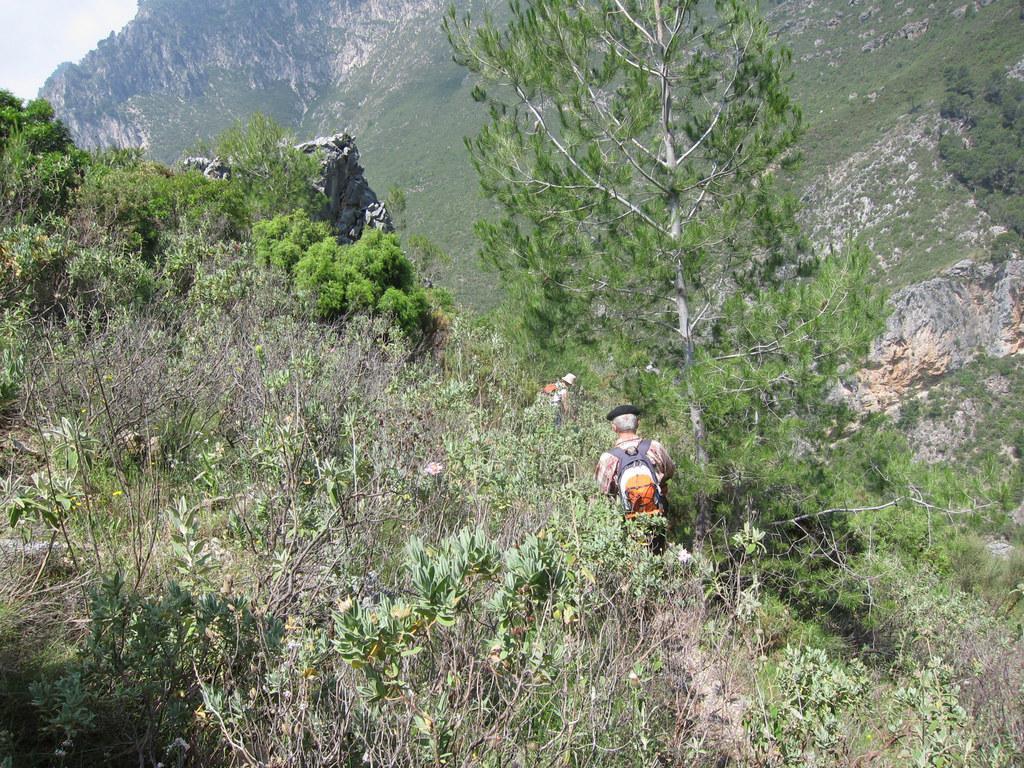How many people are present in the image? There are two people in the image. What can be seen in the background of the image? There are trees, rocks, and the sky visible in the background of the image. What type of vase is being used by the people in the image? There is no vase present in the image; it features two people and a background with trees, rocks, and the sky. 